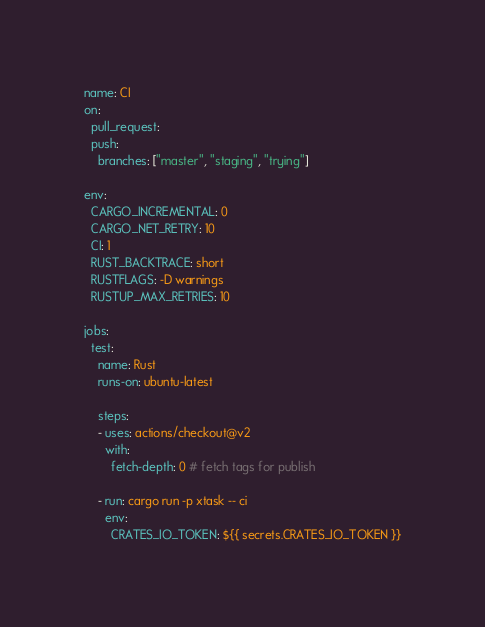<code> <loc_0><loc_0><loc_500><loc_500><_YAML_>name: CI
on:
  pull_request:
  push:
    branches: ["master", "staging", "trying"]

env:
  CARGO_INCREMENTAL: 0
  CARGO_NET_RETRY: 10
  CI: 1
  RUST_BACKTRACE: short
  RUSTFLAGS: -D warnings
  RUSTUP_MAX_RETRIES: 10

jobs:
  test:
    name: Rust
    runs-on: ubuntu-latest

    steps:
    - uses: actions/checkout@v2
      with:
        fetch-depth: 0 # fetch tags for publish

    - run: cargo run -p xtask -- ci
      env:
        CRATES_IO_TOKEN: ${{ secrets.CRATES_IO_TOKEN }}
</code> 